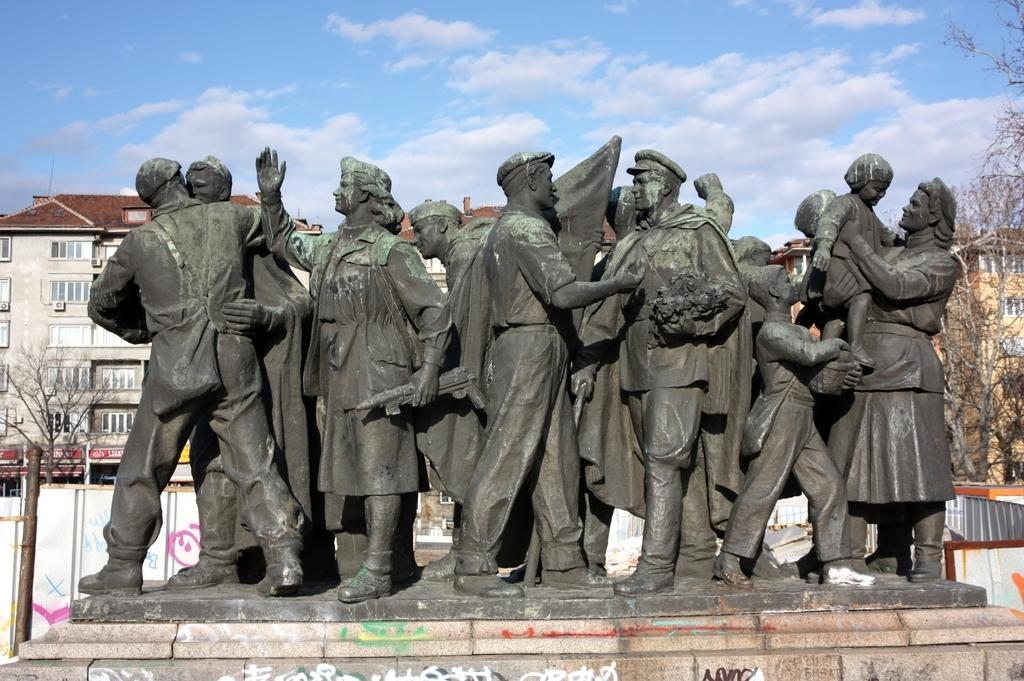What is located in the middle of the image? There are statues in the middle of the image. What can be seen behind the statues? There are trees behind the statues. What is visible in the background of the image? There are poles and buildings in the background of the image. What is visible at the top of the image? Clouds and the sky are visible at the top of the image. Can you tell me what sign the bear is holding in the image? There is no bear or sign present in the image. What is visible on the back of the statues in the image? The statues do not have a back, as they are three-dimensional objects. 